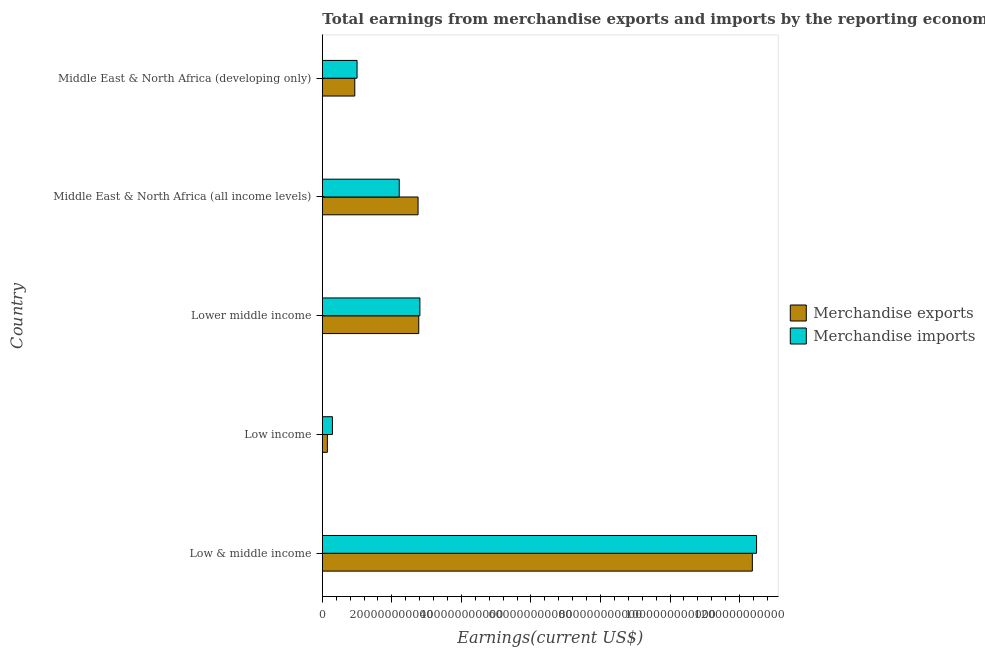How many different coloured bars are there?
Make the answer very short. 2. How many bars are there on the 4th tick from the top?
Ensure brevity in your answer.  2. How many bars are there on the 4th tick from the bottom?
Provide a short and direct response. 2. What is the label of the 1st group of bars from the top?
Your response must be concise. Middle East & North Africa (developing only). In how many cases, is the number of bars for a given country not equal to the number of legend labels?
Make the answer very short. 0. What is the earnings from merchandise imports in Low & middle income?
Give a very brief answer. 1.25e+12. Across all countries, what is the maximum earnings from merchandise imports?
Offer a very short reply. 1.25e+12. Across all countries, what is the minimum earnings from merchandise exports?
Offer a very short reply. 1.45e+1. In which country was the earnings from merchandise imports maximum?
Your response must be concise. Low & middle income. In which country was the earnings from merchandise imports minimum?
Your response must be concise. Low income. What is the total earnings from merchandise imports in the graph?
Offer a very short reply. 1.88e+12. What is the difference between the earnings from merchandise exports in Low income and that in Lower middle income?
Provide a short and direct response. -2.63e+11. What is the difference between the earnings from merchandise exports in Middle East & North Africa (all income levels) and the earnings from merchandise imports in Low income?
Your response must be concise. 2.46e+11. What is the average earnings from merchandise imports per country?
Provide a succinct answer. 3.76e+11. What is the difference between the earnings from merchandise exports and earnings from merchandise imports in Lower middle income?
Offer a very short reply. -3.28e+09. What is the ratio of the earnings from merchandise imports in Middle East & North Africa (all income levels) to that in Middle East & North Africa (developing only)?
Your answer should be very brief. 2.21. Is the difference between the earnings from merchandise imports in Lower middle income and Middle East & North Africa (developing only) greater than the difference between the earnings from merchandise exports in Lower middle income and Middle East & North Africa (developing only)?
Give a very brief answer. No. What is the difference between the highest and the second highest earnings from merchandise imports?
Your answer should be compact. 9.68e+11. What is the difference between the highest and the lowest earnings from merchandise imports?
Your response must be concise. 1.22e+12. In how many countries, is the earnings from merchandise exports greater than the average earnings from merchandise exports taken over all countries?
Ensure brevity in your answer.  1. Is the sum of the earnings from merchandise imports in Low & middle income and Middle East & North Africa (all income levels) greater than the maximum earnings from merchandise exports across all countries?
Provide a succinct answer. Yes. What does the 2nd bar from the bottom in Middle East & North Africa (all income levels) represents?
Your response must be concise. Merchandise imports. How many countries are there in the graph?
Your response must be concise. 5. What is the difference between two consecutive major ticks on the X-axis?
Provide a succinct answer. 2.00e+11. Are the values on the major ticks of X-axis written in scientific E-notation?
Ensure brevity in your answer.  No. Does the graph contain any zero values?
Keep it short and to the point. No. How many legend labels are there?
Give a very brief answer. 2. How are the legend labels stacked?
Your answer should be very brief. Vertical. What is the title of the graph?
Your answer should be very brief. Total earnings from merchandise exports and imports by the reporting economy in 2002. What is the label or title of the X-axis?
Your response must be concise. Earnings(current US$). What is the label or title of the Y-axis?
Your answer should be very brief. Country. What is the Earnings(current US$) in Merchandise exports in Low & middle income?
Give a very brief answer. 1.24e+12. What is the Earnings(current US$) in Merchandise imports in Low & middle income?
Provide a succinct answer. 1.25e+12. What is the Earnings(current US$) in Merchandise exports in Low income?
Offer a terse response. 1.45e+1. What is the Earnings(current US$) in Merchandise imports in Low income?
Give a very brief answer. 2.90e+1. What is the Earnings(current US$) in Merchandise exports in Lower middle income?
Provide a short and direct response. 2.77e+11. What is the Earnings(current US$) in Merchandise imports in Lower middle income?
Offer a very short reply. 2.81e+11. What is the Earnings(current US$) of Merchandise exports in Middle East & North Africa (all income levels)?
Make the answer very short. 2.75e+11. What is the Earnings(current US$) of Merchandise imports in Middle East & North Africa (all income levels)?
Your response must be concise. 2.21e+11. What is the Earnings(current US$) in Merchandise exports in Middle East & North Africa (developing only)?
Your answer should be very brief. 9.33e+1. What is the Earnings(current US$) in Merchandise imports in Middle East & North Africa (developing only)?
Your response must be concise. 9.99e+1. Across all countries, what is the maximum Earnings(current US$) in Merchandise exports?
Make the answer very short. 1.24e+12. Across all countries, what is the maximum Earnings(current US$) in Merchandise imports?
Ensure brevity in your answer.  1.25e+12. Across all countries, what is the minimum Earnings(current US$) of Merchandise exports?
Your answer should be compact. 1.45e+1. Across all countries, what is the minimum Earnings(current US$) of Merchandise imports?
Make the answer very short. 2.90e+1. What is the total Earnings(current US$) of Merchandise exports in the graph?
Make the answer very short. 1.90e+12. What is the total Earnings(current US$) in Merchandise imports in the graph?
Offer a terse response. 1.88e+12. What is the difference between the Earnings(current US$) in Merchandise exports in Low & middle income and that in Low income?
Give a very brief answer. 1.22e+12. What is the difference between the Earnings(current US$) of Merchandise imports in Low & middle income and that in Low income?
Keep it short and to the point. 1.22e+12. What is the difference between the Earnings(current US$) of Merchandise exports in Low & middle income and that in Lower middle income?
Your answer should be very brief. 9.59e+11. What is the difference between the Earnings(current US$) of Merchandise imports in Low & middle income and that in Lower middle income?
Provide a succinct answer. 9.68e+11. What is the difference between the Earnings(current US$) in Merchandise exports in Low & middle income and that in Middle East & North Africa (all income levels)?
Your response must be concise. 9.61e+11. What is the difference between the Earnings(current US$) in Merchandise imports in Low & middle income and that in Middle East & North Africa (all income levels)?
Make the answer very short. 1.03e+12. What is the difference between the Earnings(current US$) of Merchandise exports in Low & middle income and that in Middle East & North Africa (developing only)?
Offer a very short reply. 1.14e+12. What is the difference between the Earnings(current US$) of Merchandise imports in Low & middle income and that in Middle East & North Africa (developing only)?
Provide a succinct answer. 1.15e+12. What is the difference between the Earnings(current US$) of Merchandise exports in Low income and that in Lower middle income?
Provide a short and direct response. -2.63e+11. What is the difference between the Earnings(current US$) in Merchandise imports in Low income and that in Lower middle income?
Keep it short and to the point. -2.52e+11. What is the difference between the Earnings(current US$) of Merchandise exports in Low income and that in Middle East & North Africa (all income levels)?
Make the answer very short. -2.61e+11. What is the difference between the Earnings(current US$) of Merchandise imports in Low income and that in Middle East & North Africa (all income levels)?
Keep it short and to the point. -1.92e+11. What is the difference between the Earnings(current US$) in Merchandise exports in Low income and that in Middle East & North Africa (developing only)?
Your answer should be compact. -7.88e+1. What is the difference between the Earnings(current US$) in Merchandise imports in Low income and that in Middle East & North Africa (developing only)?
Give a very brief answer. -7.08e+1. What is the difference between the Earnings(current US$) of Merchandise exports in Lower middle income and that in Middle East & North Africa (all income levels)?
Provide a succinct answer. 1.98e+09. What is the difference between the Earnings(current US$) in Merchandise imports in Lower middle income and that in Middle East & North Africa (all income levels)?
Your answer should be very brief. 5.94e+1. What is the difference between the Earnings(current US$) of Merchandise exports in Lower middle income and that in Middle East & North Africa (developing only)?
Your answer should be very brief. 1.84e+11. What is the difference between the Earnings(current US$) in Merchandise imports in Lower middle income and that in Middle East & North Africa (developing only)?
Provide a succinct answer. 1.81e+11. What is the difference between the Earnings(current US$) in Merchandise exports in Middle East & North Africa (all income levels) and that in Middle East & North Africa (developing only)?
Your answer should be compact. 1.82e+11. What is the difference between the Earnings(current US$) of Merchandise imports in Middle East & North Africa (all income levels) and that in Middle East & North Africa (developing only)?
Provide a short and direct response. 1.21e+11. What is the difference between the Earnings(current US$) of Merchandise exports in Low & middle income and the Earnings(current US$) of Merchandise imports in Low income?
Your answer should be compact. 1.21e+12. What is the difference between the Earnings(current US$) in Merchandise exports in Low & middle income and the Earnings(current US$) in Merchandise imports in Lower middle income?
Make the answer very short. 9.56e+11. What is the difference between the Earnings(current US$) in Merchandise exports in Low & middle income and the Earnings(current US$) in Merchandise imports in Middle East & North Africa (all income levels)?
Give a very brief answer. 1.02e+12. What is the difference between the Earnings(current US$) in Merchandise exports in Low & middle income and the Earnings(current US$) in Merchandise imports in Middle East & North Africa (developing only)?
Your answer should be compact. 1.14e+12. What is the difference between the Earnings(current US$) of Merchandise exports in Low income and the Earnings(current US$) of Merchandise imports in Lower middle income?
Provide a short and direct response. -2.66e+11. What is the difference between the Earnings(current US$) of Merchandise exports in Low income and the Earnings(current US$) of Merchandise imports in Middle East & North Africa (all income levels)?
Give a very brief answer. -2.07e+11. What is the difference between the Earnings(current US$) in Merchandise exports in Low income and the Earnings(current US$) in Merchandise imports in Middle East & North Africa (developing only)?
Offer a terse response. -8.54e+1. What is the difference between the Earnings(current US$) in Merchandise exports in Lower middle income and the Earnings(current US$) in Merchandise imports in Middle East & North Africa (all income levels)?
Offer a terse response. 5.61e+1. What is the difference between the Earnings(current US$) of Merchandise exports in Lower middle income and the Earnings(current US$) of Merchandise imports in Middle East & North Africa (developing only)?
Offer a terse response. 1.77e+11. What is the difference between the Earnings(current US$) of Merchandise exports in Middle East & North Africa (all income levels) and the Earnings(current US$) of Merchandise imports in Middle East & North Africa (developing only)?
Your answer should be very brief. 1.75e+11. What is the average Earnings(current US$) of Merchandise exports per country?
Provide a short and direct response. 3.79e+11. What is the average Earnings(current US$) of Merchandise imports per country?
Give a very brief answer. 3.76e+11. What is the difference between the Earnings(current US$) of Merchandise exports and Earnings(current US$) of Merchandise imports in Low & middle income?
Make the answer very short. -1.21e+1. What is the difference between the Earnings(current US$) in Merchandise exports and Earnings(current US$) in Merchandise imports in Low income?
Your answer should be compact. -1.45e+1. What is the difference between the Earnings(current US$) of Merchandise exports and Earnings(current US$) of Merchandise imports in Lower middle income?
Your answer should be compact. -3.28e+09. What is the difference between the Earnings(current US$) in Merchandise exports and Earnings(current US$) in Merchandise imports in Middle East & North Africa (all income levels)?
Your response must be concise. 5.41e+1. What is the difference between the Earnings(current US$) in Merchandise exports and Earnings(current US$) in Merchandise imports in Middle East & North Africa (developing only)?
Your response must be concise. -6.55e+09. What is the ratio of the Earnings(current US$) in Merchandise exports in Low & middle income to that in Low income?
Offer a very short reply. 85.17. What is the ratio of the Earnings(current US$) of Merchandise imports in Low & middle income to that in Low income?
Your answer should be compact. 43.01. What is the ratio of the Earnings(current US$) of Merchandise exports in Low & middle income to that in Lower middle income?
Your answer should be compact. 4.46. What is the ratio of the Earnings(current US$) of Merchandise imports in Low & middle income to that in Lower middle income?
Make the answer very short. 4.45. What is the ratio of the Earnings(current US$) in Merchandise exports in Low & middle income to that in Middle East & North Africa (all income levels)?
Ensure brevity in your answer.  4.49. What is the ratio of the Earnings(current US$) in Merchandise imports in Low & middle income to that in Middle East & North Africa (all income levels)?
Ensure brevity in your answer.  5.65. What is the ratio of the Earnings(current US$) of Merchandise exports in Low & middle income to that in Middle East & North Africa (developing only)?
Provide a succinct answer. 13.25. What is the ratio of the Earnings(current US$) in Merchandise imports in Low & middle income to that in Middle East & North Africa (developing only)?
Provide a succinct answer. 12.5. What is the ratio of the Earnings(current US$) of Merchandise exports in Low income to that in Lower middle income?
Your response must be concise. 0.05. What is the ratio of the Earnings(current US$) in Merchandise imports in Low income to that in Lower middle income?
Keep it short and to the point. 0.1. What is the ratio of the Earnings(current US$) of Merchandise exports in Low income to that in Middle East & North Africa (all income levels)?
Ensure brevity in your answer.  0.05. What is the ratio of the Earnings(current US$) in Merchandise imports in Low income to that in Middle East & North Africa (all income levels)?
Your answer should be very brief. 0.13. What is the ratio of the Earnings(current US$) in Merchandise exports in Low income to that in Middle East & North Africa (developing only)?
Your answer should be very brief. 0.16. What is the ratio of the Earnings(current US$) of Merchandise imports in Low income to that in Middle East & North Africa (developing only)?
Provide a succinct answer. 0.29. What is the ratio of the Earnings(current US$) of Merchandise exports in Lower middle income to that in Middle East & North Africa (all income levels)?
Your response must be concise. 1.01. What is the ratio of the Earnings(current US$) in Merchandise imports in Lower middle income to that in Middle East & North Africa (all income levels)?
Give a very brief answer. 1.27. What is the ratio of the Earnings(current US$) in Merchandise exports in Lower middle income to that in Middle East & North Africa (developing only)?
Your answer should be compact. 2.97. What is the ratio of the Earnings(current US$) of Merchandise imports in Lower middle income to that in Middle East & North Africa (developing only)?
Keep it short and to the point. 2.81. What is the ratio of the Earnings(current US$) of Merchandise exports in Middle East & North Africa (all income levels) to that in Middle East & North Africa (developing only)?
Ensure brevity in your answer.  2.95. What is the ratio of the Earnings(current US$) of Merchandise imports in Middle East & North Africa (all income levels) to that in Middle East & North Africa (developing only)?
Your answer should be compact. 2.21. What is the difference between the highest and the second highest Earnings(current US$) of Merchandise exports?
Give a very brief answer. 9.59e+11. What is the difference between the highest and the second highest Earnings(current US$) in Merchandise imports?
Your answer should be compact. 9.68e+11. What is the difference between the highest and the lowest Earnings(current US$) in Merchandise exports?
Your answer should be very brief. 1.22e+12. What is the difference between the highest and the lowest Earnings(current US$) in Merchandise imports?
Give a very brief answer. 1.22e+12. 